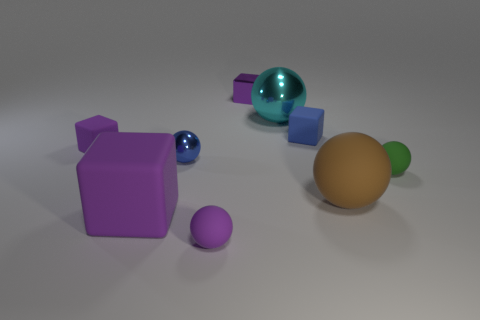Subtract all purple cubes. How many were subtracted if there are1purple cubes left? 2 Subtract all brown spheres. How many spheres are left? 4 Subtract all yellow balls. How many purple blocks are left? 3 Subtract all purple balls. How many balls are left? 4 Add 1 small green spheres. How many objects exist? 10 Subtract 3 balls. How many balls are left? 2 Subtract all spheres. How many objects are left? 4 Add 5 purple cylinders. How many purple cylinders exist? 5 Subtract 0 red cylinders. How many objects are left? 9 Subtract all brown cubes. Subtract all cyan spheres. How many cubes are left? 4 